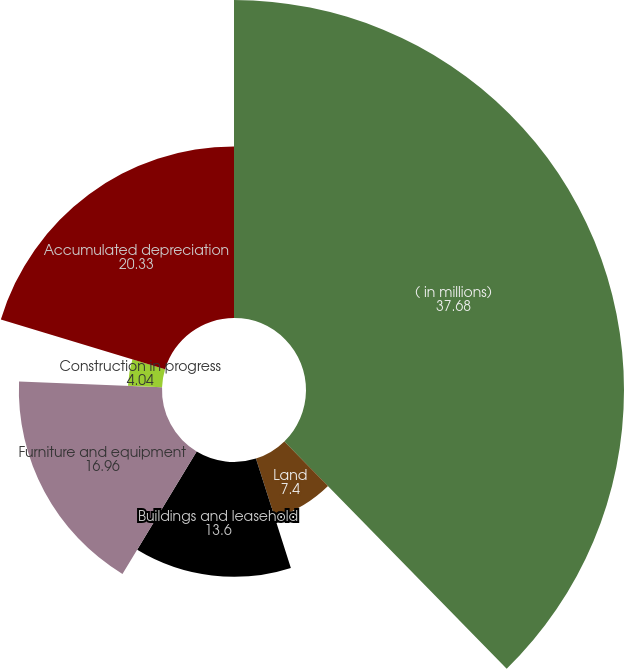Convert chart. <chart><loc_0><loc_0><loc_500><loc_500><pie_chart><fcel>( in millions)<fcel>Land<fcel>Buildings and leasehold<fcel>Furniture and equipment<fcel>Construction in progress<fcel>Accumulated depreciation<nl><fcel>37.68%<fcel>7.4%<fcel>13.6%<fcel>16.96%<fcel>4.04%<fcel>20.33%<nl></chart> 